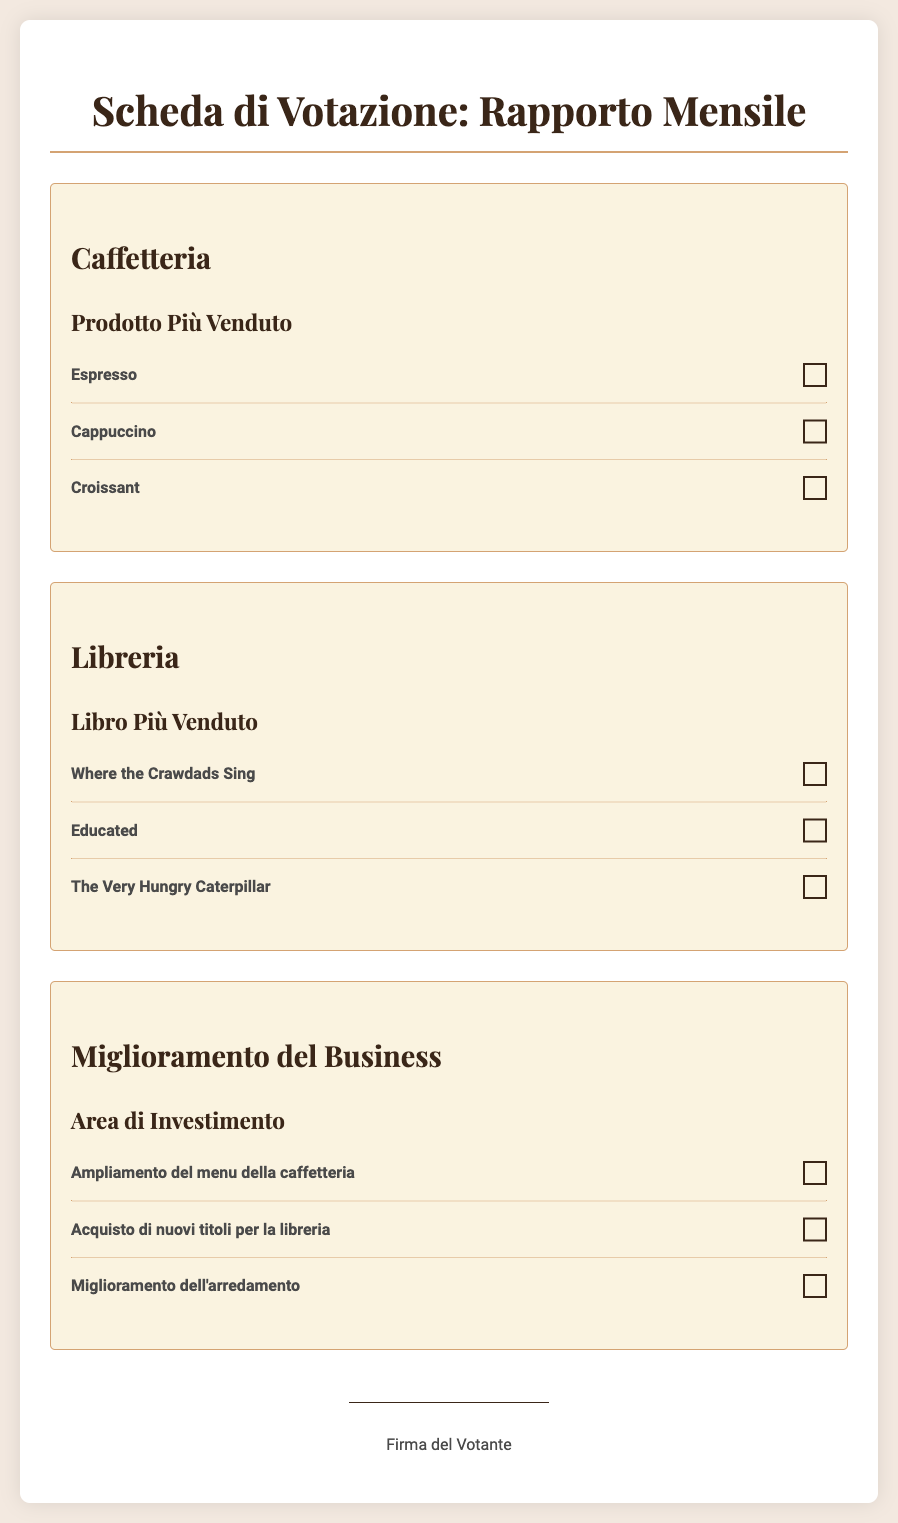Qual è il prodotto più venduto nella caffetteria? Il prodotto più venduto è elencato nella sezione della caffetteria, dove il primo prodotto è Espresso.
Answer: Espresso Qual è il libro più venduto nella libreria? Il libro più venduto è menzionato nella sezione della libreria, dove il primo libro è "Where the Crawdads Sing".
Answer: Where the Crawdads Sing Qual è un'area di investimento proposta per il miglioramento del business? Le aree di investimento sono elencate nella sezione "Miglioramento del Business", una delle opzioni è "Ampliamento del menu della caffetteria".
Answer: Ampliamento del menu della caffetteria Quanti prodotti ci sono listati nella sezione della caffetteria? Nella sezione della caffetteria sono elencati tre prodotti.
Answer: 3 Quanti libri ci sono listati nella sezione della libreria? Nella sezione della libreria sono menzionati tre libri.
Answer: 3 Qual è il nome del secondo libro più venduto? Il secondo libro è "Educated", elencato nella sezione della libreria.
Answer: Educated Qual è l'argomento principale del documento? Il documento è una scheda di votazione sul rapporto mensile della caffetteria e libreria.
Answer: Rapporto mensile Quale prodotto è elencato come terzo prodotto più venduto nella caffetteria? Nella sezione della caffetteria, il terzo prodotto è Croissant.
Answer: Croissant Quali sono le due categorie principali discusse nel documento? Le categorie principali sono "Caffetteria" e "Libreria".
Answer: Caffetteria, Libreria 